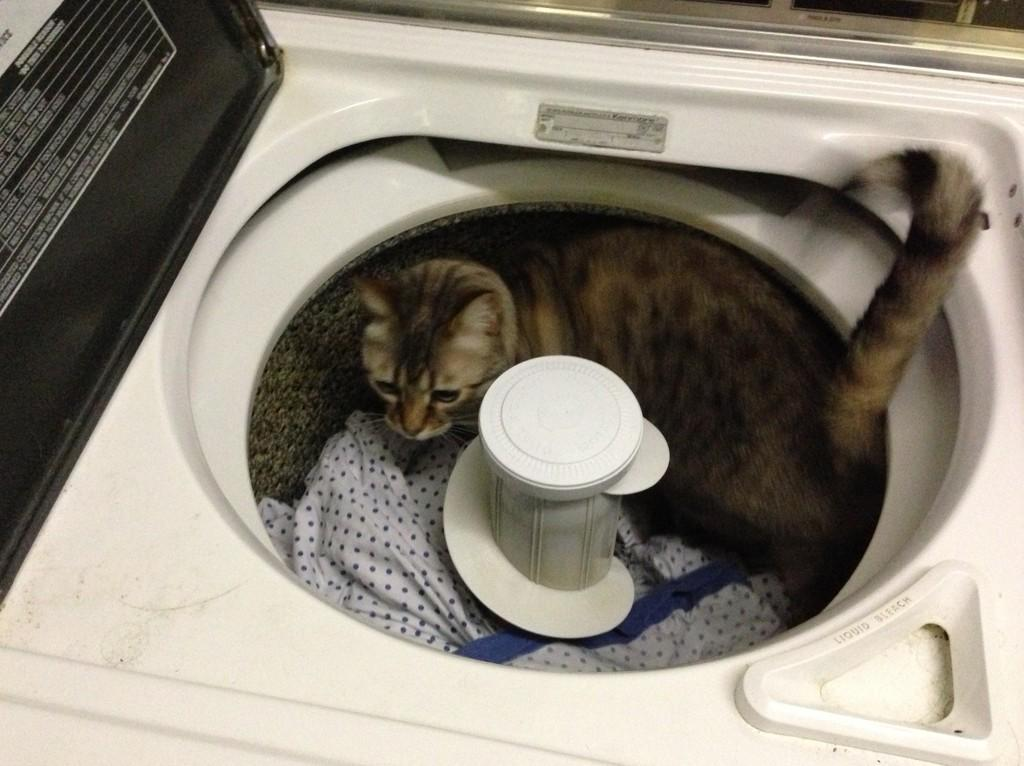What type of animal is present in the image? There is a cat in the image. What is the cat doing in the image? The provided facts do not specify what the cat is doing. What is located inside the washing machine in the image? There is cloth in the washing machine in the image. What is the purpose of the washing machine in the image? The washing machine is likely used for cleaning clothes, as it contains cloth. What expert opinion is being sought in the image? There is no indication in the image that an expert opinion is being sought. What belief is being expressed by the cat in the image? Cats do not express beliefs, as they are animals and not capable of human-like thought processes. 